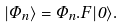Convert formula to latex. <formula><loc_0><loc_0><loc_500><loc_500>| \Phi _ { n } \rangle = { \Phi _ { n } } . { F } | 0 \rangle .</formula> 